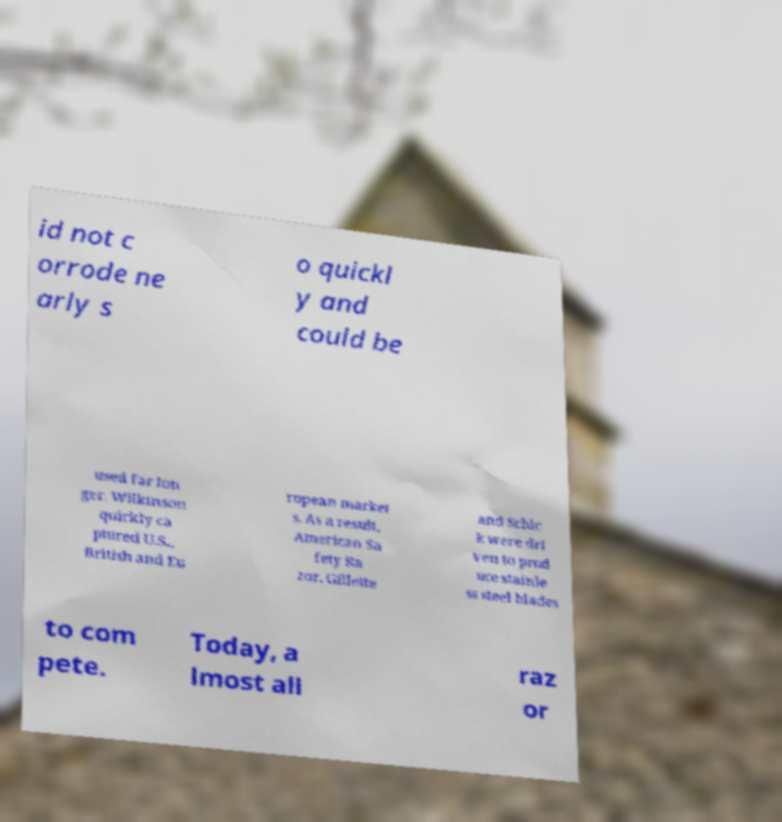Can you accurately transcribe the text from the provided image for me? id not c orrode ne arly s o quickl y and could be used far lon ger. Wilkinson quickly ca ptured U.S., British and Eu ropean market s. As a result, American Sa fety Ra zor, Gillette and Schic k were dri ven to prod uce stainle ss steel blades to com pete. Today, a lmost all raz or 